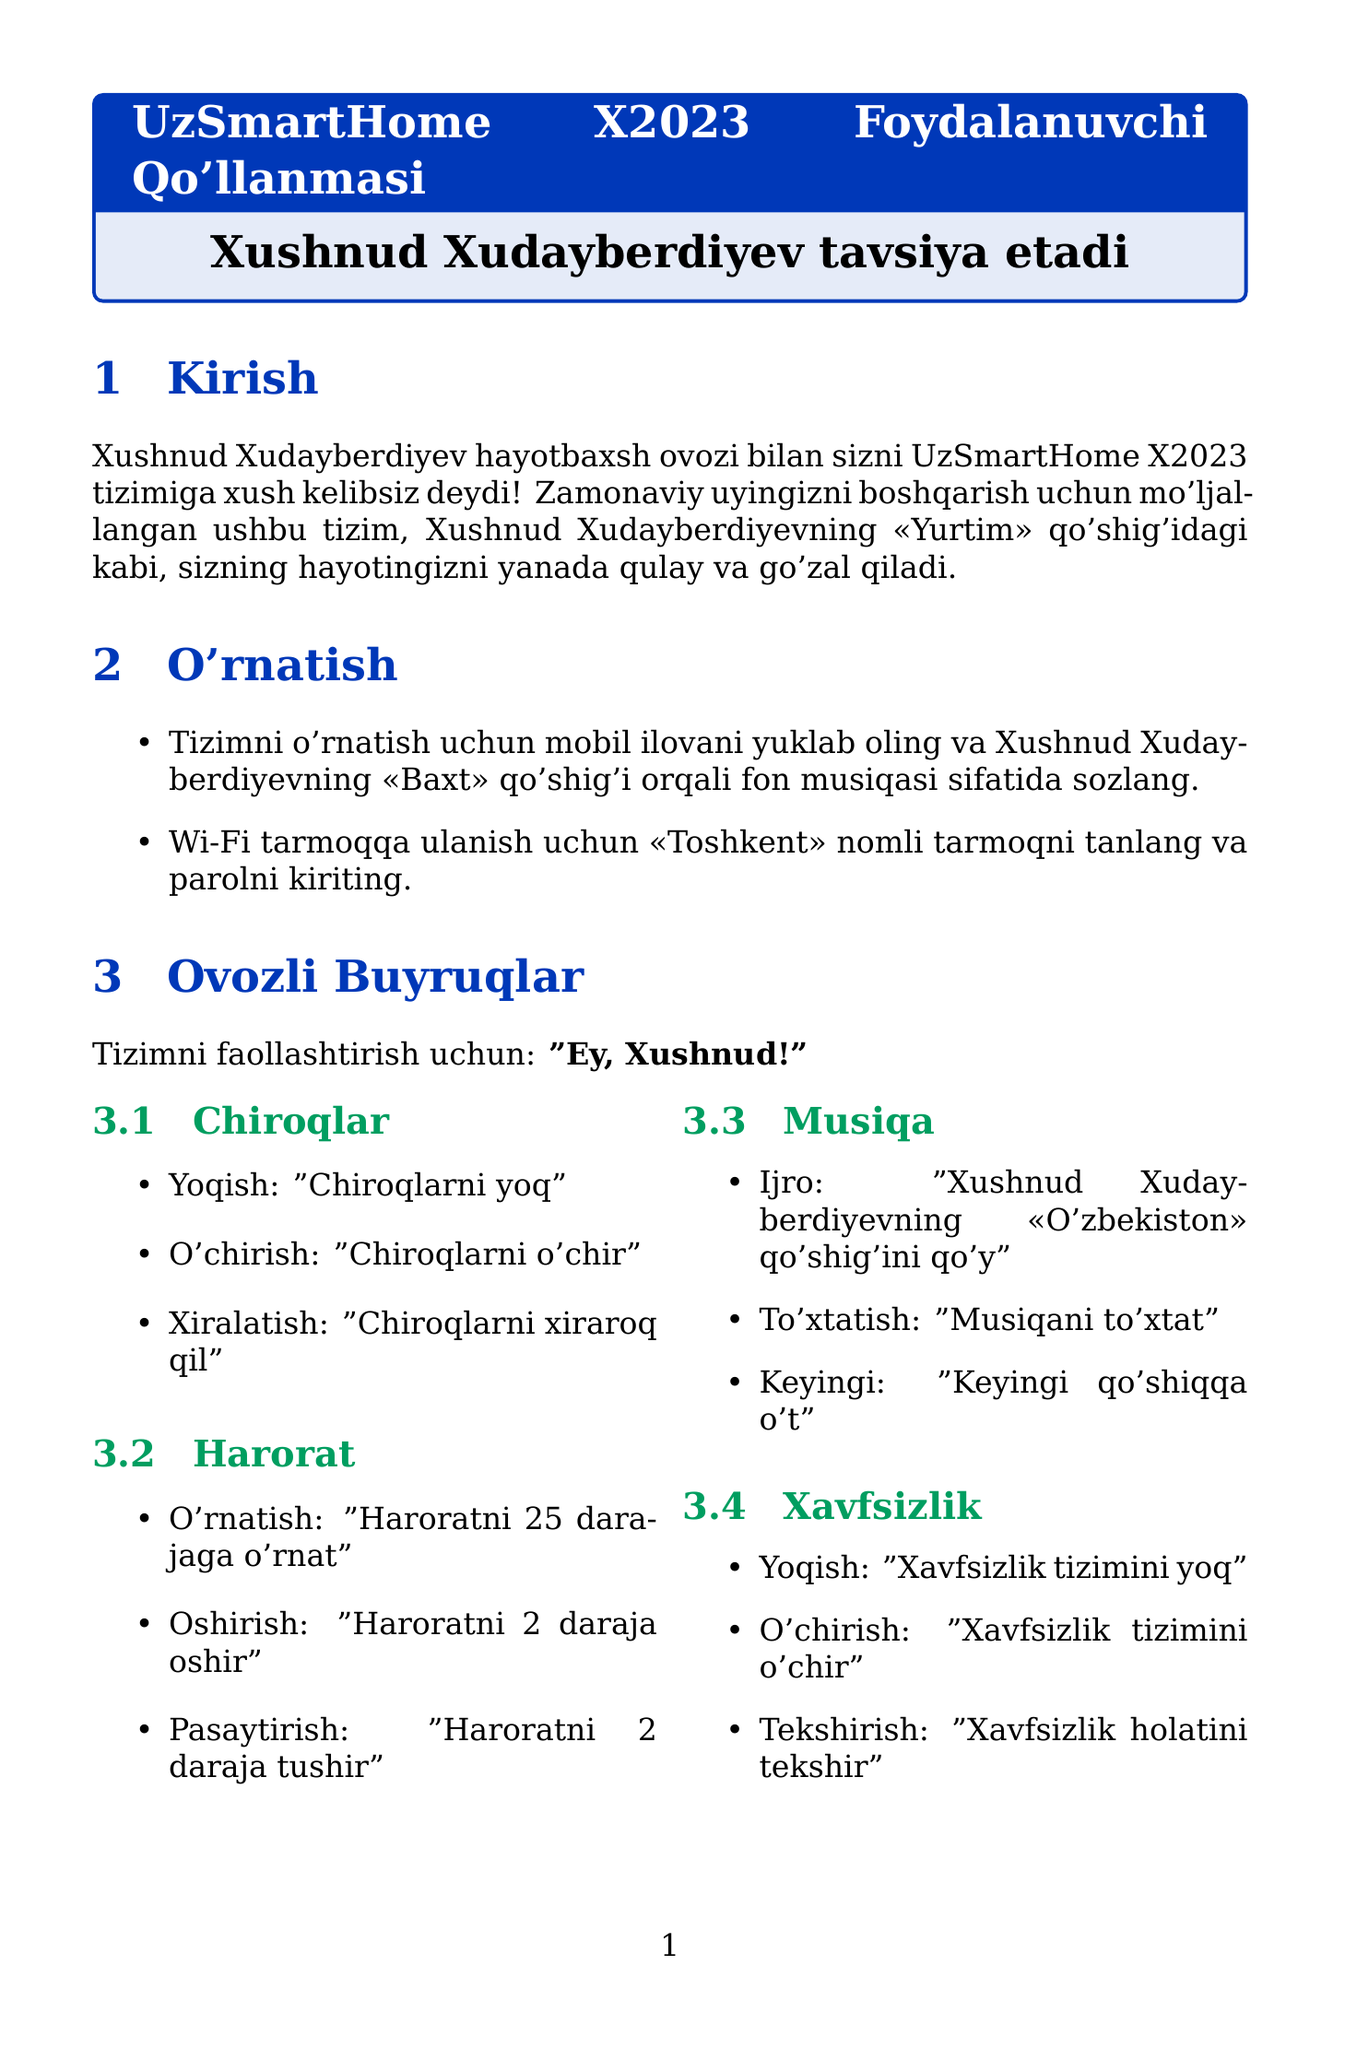What is the brand name of the smart home system? The brand name is stated in the document as "UzSmartHome".
Answer: UzSmartHome What language is the system set to operate in? The document specifies that the language for the smart home system is "Uzbek".
Answer: Uzbek What is the activation phrase for the voice commands? The document mentions that the activation phrase is "Ey, Xushnud!".
Answer: Ey, Xushnud! What temperature should the system be set to for the desired command? The document indicates the command to set temperature is "Haroratni 25 darajaga o'rnat".
Answer: 25 darajaga How often should the remote control batteries be replaced? According to the maintenance section, the batteries should be replaced "Har 6 oyda".
Answer: Har 6 oyda What command is used to start the washing machine? The document outlines that the command to start the washing machine is "Kir yuvishni boshla".
Answer: Kir yuvishni boshla What should you say to check for software updates? It is specified that you should ask "Yangilanishlar mavjudmi?" to check for updates.
Answer: Yangilanishlar mavjudmi? What step is recommended if you face connectivity issues? The document advises checking the Wi-Fi connection by saying "Internet tezligini tekshir".
Answer: Internet tezligini tekshir What music track is recommended to play for a pleasant ambiance? It suggests playing "Xushnud Xudayberdiyevning «O'zbekiston» qo'shig'ini qo'y" for music.
Answer: Xushnud Xudayberdiyevning «O'zbekiston» qo'shig'ini qo'y 